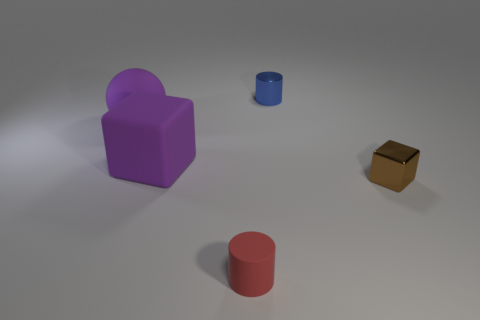Can you describe the lighting and shadow effects in the image? The image has a softly lit ambiance with diffused shadows suggesting an overhead light source, which creates a gentle contrast and subtly highlights the shapes and colors of the objects. What might be the purpose of these objects being together in this setting? This setting could be designed for educational purposes, perhaps to teach about shapes, colors, and sizes, or it could simply be an artistic composition playing with geometric forms and spatial relationships. 